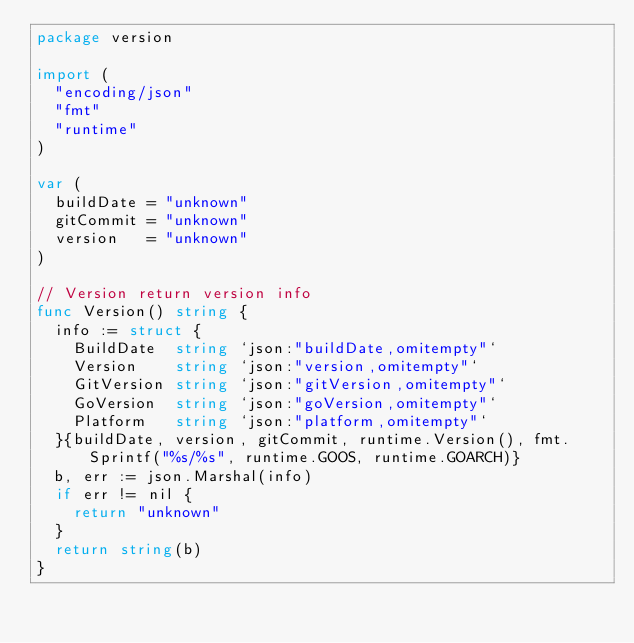Convert code to text. <code><loc_0><loc_0><loc_500><loc_500><_Go_>package version

import (
	"encoding/json"
	"fmt"
	"runtime"
)

var (
	buildDate = "unknown"
	gitCommit = "unknown"
	version   = "unknown"
)

// Version return version info
func Version() string {
	info := struct {
		BuildDate  string `json:"buildDate,omitempty"`
		Version    string `json:"version,omitempty"`
		GitVersion string `json:"gitVersion,omitempty"`
		GoVersion  string `json:"goVersion,omitempty"`
		Platform   string `json:"platform,omitempty"`
	}{buildDate, version, gitCommit, runtime.Version(), fmt.Sprintf("%s/%s", runtime.GOOS, runtime.GOARCH)}
	b, err := json.Marshal(info)
	if err != nil {
		return "unknown"
	}
	return string(b)
}
</code> 